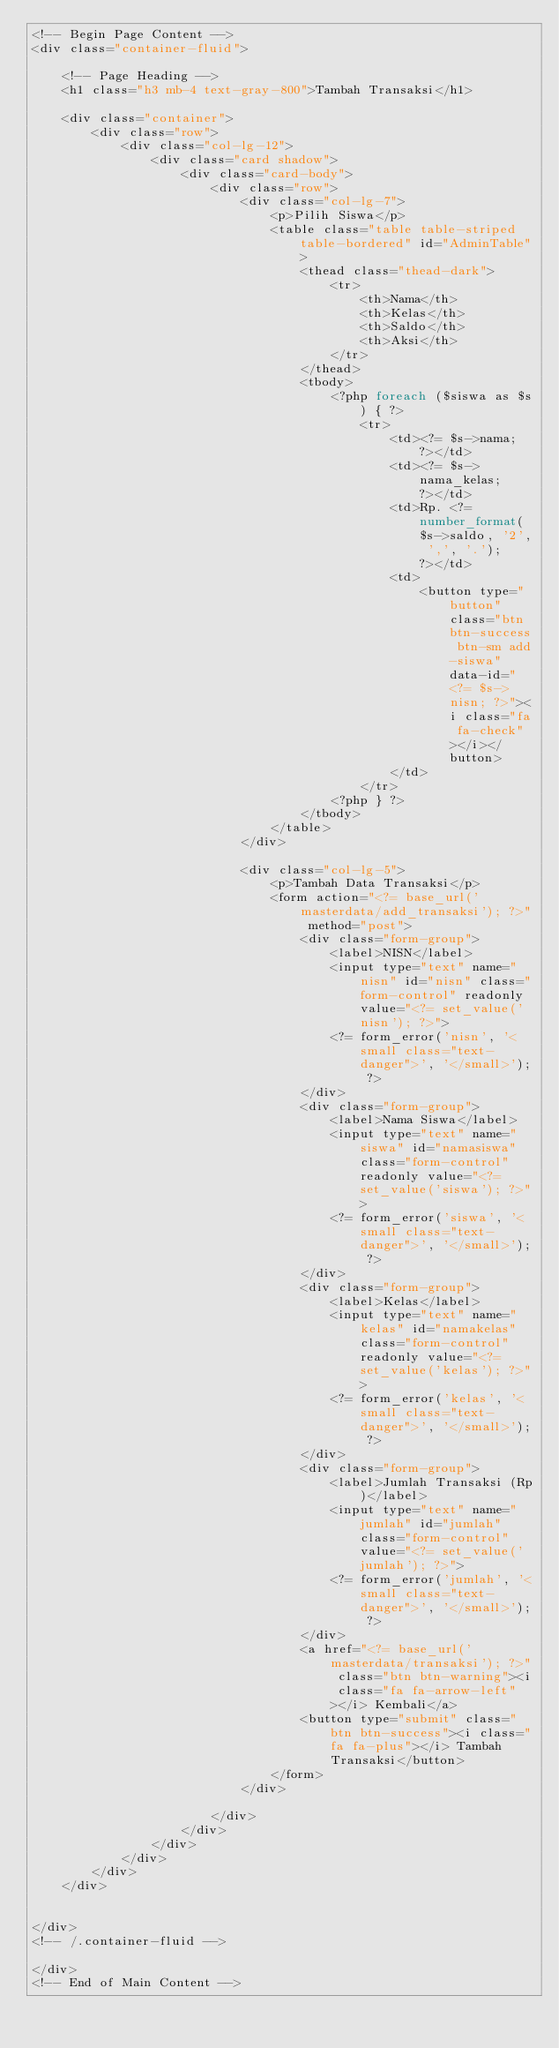Convert code to text. <code><loc_0><loc_0><loc_500><loc_500><_PHP_><!-- Begin Page Content -->
<div class="container-fluid">

    <!-- Page Heading -->
    <h1 class="h3 mb-4 text-gray-800">Tambah Transaksi</h1>

    <div class="container">
        <div class="row">
            <div class="col-lg-12">
                <div class="card shadow">
                    <div class="card-body">
                        <div class="row">
                            <div class="col-lg-7">
                                <p>Pilih Siswa</p>
                                <table class="table table-striped table-bordered" id="AdminTable">
                                    <thead class="thead-dark">
                                        <tr>
                                            <th>Nama</th>
                                            <th>Kelas</th>
                                            <th>Saldo</th>
                                            <th>Aksi</th>
                                        </tr>
                                    </thead>
                                    <tbody>
                                        <?php foreach ($siswa as $s) { ?>
                                            <tr>
                                                <td><?= $s->nama; ?></td>
                                                <td><?= $s->nama_kelas; ?></td>
                                                <td>Rp. <?= number_format($s->saldo, '2', ',', '.'); ?></td>
                                                <td>
                                                    <button type="button" class="btn btn-success btn-sm add-siswa" data-id="<?= $s->nisn; ?>"><i class="fa fa-check"></i></button>
                                                </td>
                                            </tr>
                                        <?php } ?>
                                    </tbody>
                                </table>
                            </div>

                            <div class="col-lg-5">
                                <p>Tambah Data Transaksi</p>
                                <form action="<?= base_url('masterdata/add_transaksi'); ?>" method="post">
                                    <div class="form-group">
                                        <label>NISN</label>
                                        <input type="text" name="nisn" id="nisn" class="form-control" readonly value="<?= set_value('nisn'); ?>">
                                        <?= form_error('nisn', '<small class="text-danger">', '</small>'); ?>
                                    </div>
                                    <div class="form-group">
                                        <label>Nama Siswa</label>
                                        <input type="text" name="siswa" id="namasiswa" class="form-control" readonly value="<?= set_value('siswa'); ?>">
                                        <?= form_error('siswa', '<small class="text-danger">', '</small>'); ?>
                                    </div>
                                    <div class="form-group">
                                        <label>Kelas</label>
                                        <input type="text" name="kelas" id="namakelas" class="form-control" readonly value="<?= set_value('kelas'); ?>">
                                        <?= form_error('kelas', '<small class="text-danger">', '</small>'); ?>
                                    </div>
                                    <div class="form-group">
                                        <label>Jumlah Transaksi (Rp)</label>
                                        <input type="text" name="jumlah" id="jumlah" class="form-control" value="<?= set_value('jumlah'); ?>">
                                        <?= form_error('jumlah', '<small class="text-danger">', '</small>'); ?>
                                    </div>
                                    <a href="<?= base_url('masterdata/transaksi'); ?>" class="btn btn-warning"><i class="fa fa-arrow-left"></i> Kembali</a>
                                    <button type="submit" class="btn btn-success"><i class="fa fa-plus"></i> Tambah Transaksi</button>
                                </form>
                            </div>

                        </div>
                    </div>
                </div>
            </div>
        </div>
    </div>


</div>
<!-- /.container-fluid -->

</div>
<!-- End of Main Content --></code> 